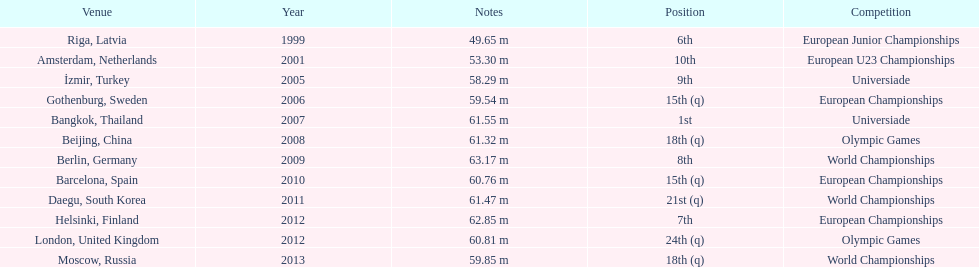How what listed year was a distance of only 53.30m reached? 2001. 